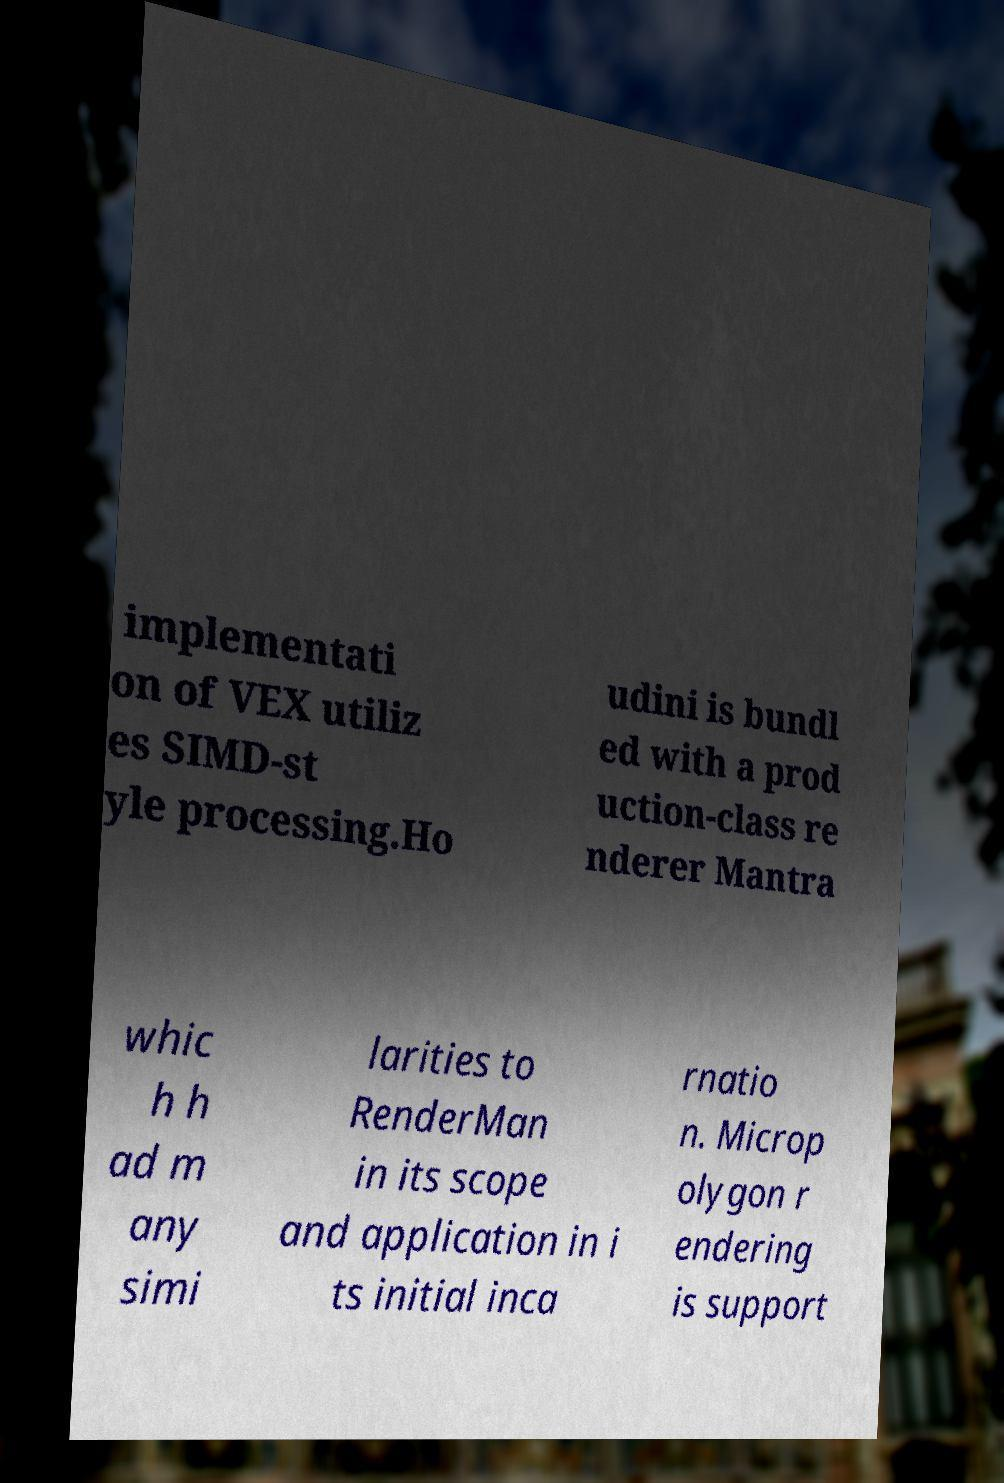Please identify and transcribe the text found in this image. implementati on of VEX utiliz es SIMD-st yle processing.Ho udini is bundl ed with a prod uction-class re nderer Mantra whic h h ad m any simi larities to RenderMan in its scope and application in i ts initial inca rnatio n. Microp olygon r endering is support 